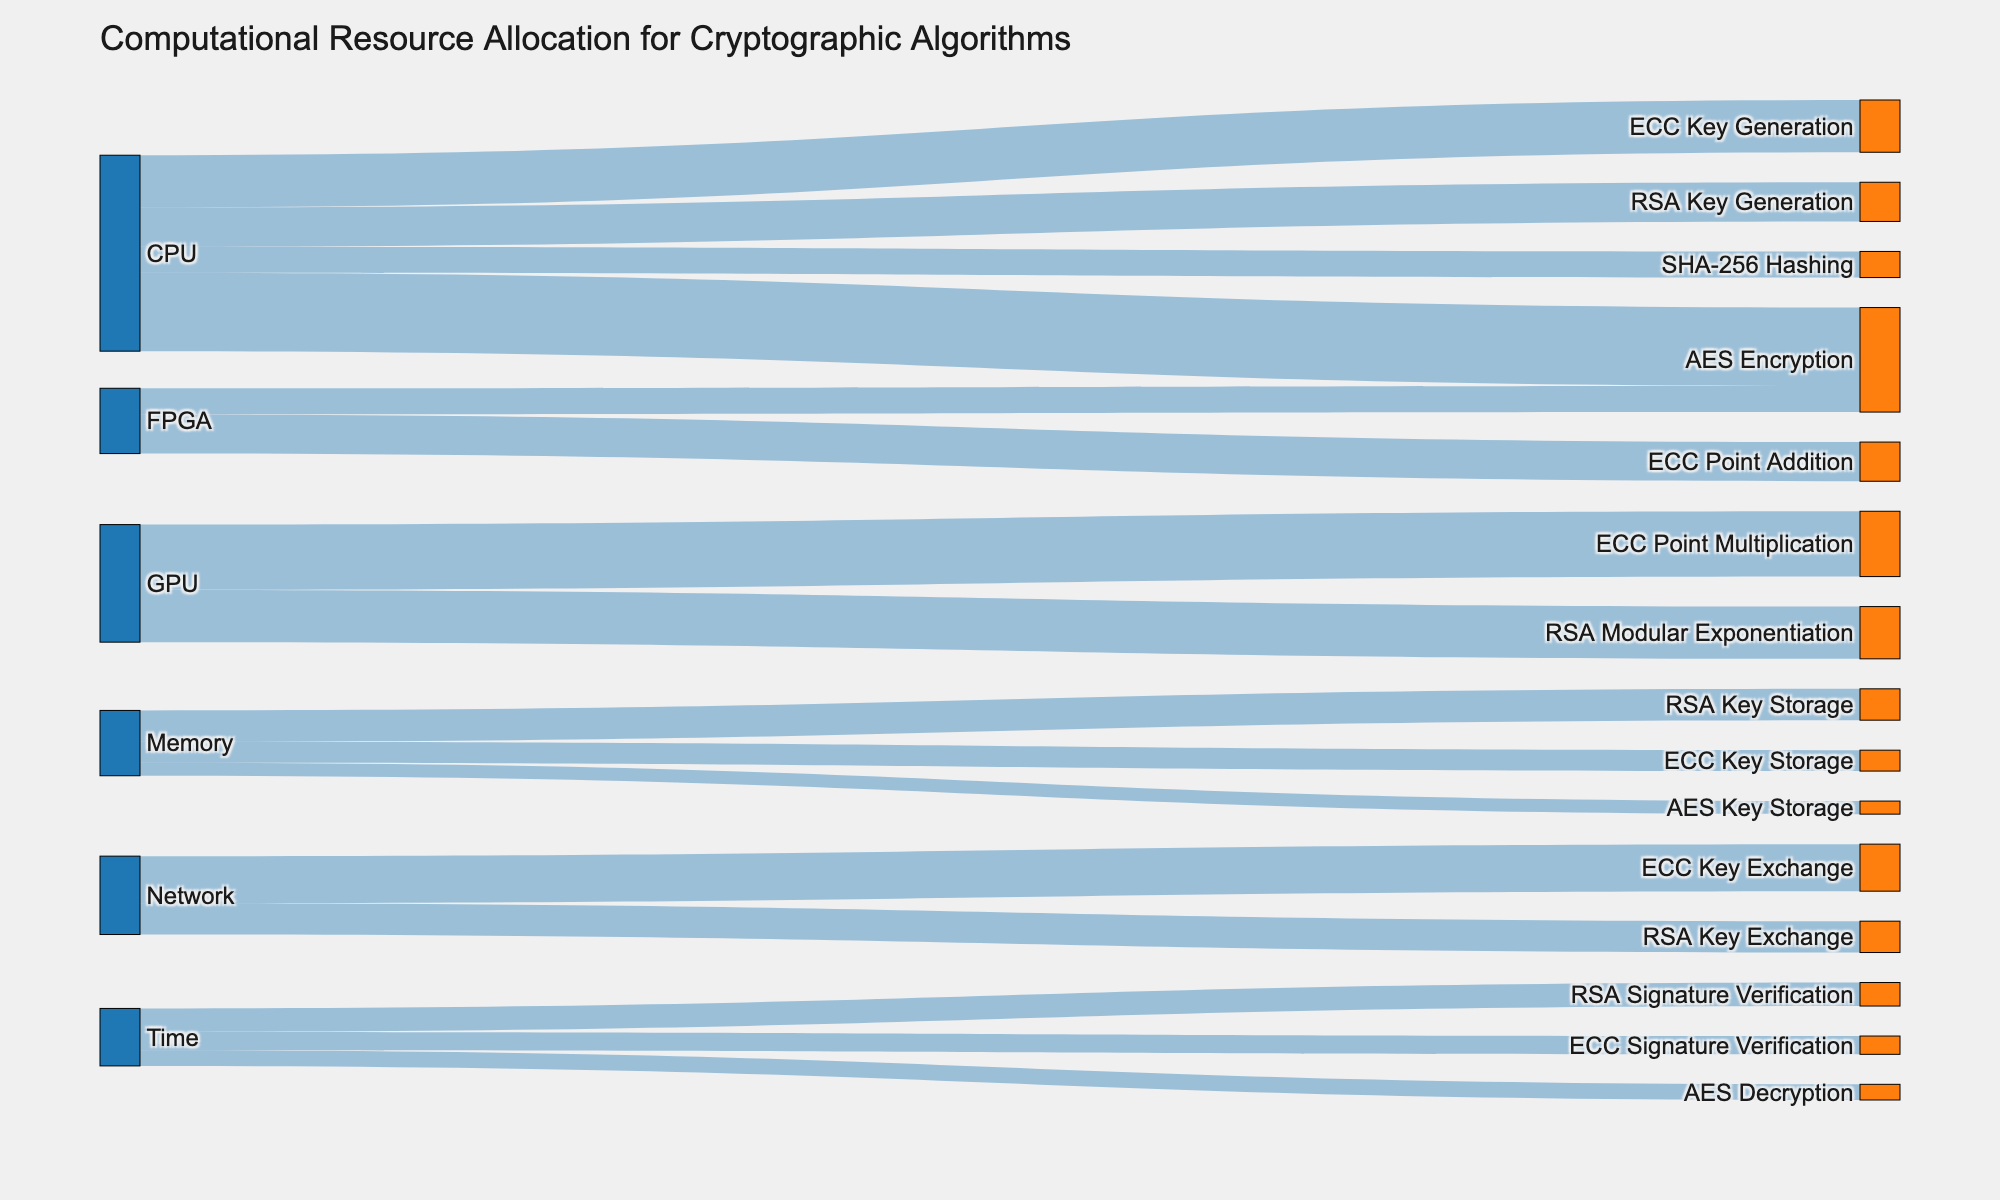What is the title of the Sankey diagram? The title is located at the top of the diagram. It is "Computational Resource Allocation for Cryptographic Algorithms"
Answer: "Computational Resource Allocation for Cryptographic Algorithms" Which computational resource has the highest allocation for ECC-related tasks? From the diagram, examining the connections to ECC-related tasks (ECC Key Generation, ECC Point Multiplication, ECC Point Addition, ECC Key Storage, ECC Key Exchange, ECC Signature Verification), the GPU has a major role for ECC Point Multiplication (25) and ECC Point Addition (15). Summing these gives 40.
Answer: GPU How many different computational resources are represented in the diagram? The different computational resources are indicated by distinct sources connected to a variety of targets. There are four sources: CPU, GPU, FPGA, and Memory.
Answer: 4 What is the total value of computational resources allocated for RSA-related tasks? To find the total value for RSA-related tasks (RSA Key Generation, RSA Modular Exponentiation, RSA Key Storage, RSA Key Exchange, RSA Signature Verification), sum the values from the respective source-targets: 15 (CPU to RSA Key Generation) + 20 (GPU to RSA Modular Exponentiation) + 12 (Memory to RSA Key Storage) + 12 (Network to RSA Key Exchange) + 9 (Time to RSA Signature Verification) = 68.
Answer: 68 Which task utilizes the most computational resources from the FPGA? The FPGA is associated with ECC Point Addition (15) and AES Encryption (10). Comparing these, ECC Point Addition utilizes more resources.
Answer: ECC Point Addition Are there any targets that receive computational resources from more than one type of source? By studying the target nodes, ECC Key Generation receives resources from CPU (20), indicating it comes from a single source. However, examining ECC Point Multiplication (GPU 25) and ECC Point Addition (FPGA 15) suggest no overlap in sources for other targets. A close inspection reveals that RSA Key Exchange receives resources from both Network (12) and Time (9), suggesting it's also connected to more than one source. Summing it confirms a unique allocation per source type.
Answer: No What is the total value of resources coming from the CPU? The CPU distributes resources to multiple targets. Summing these allocations: 30 (AES Encryption) + 15 (RSA Key Generation) + 20 (ECC Key Generation) + 10 (SHA-256 Hashing) results in 75 total from CPU.
Answer: 75 Which algorithm receives the least amount of computational resources for decryption? For decryption tasks, we notice AES Decryption which has a value of 6 directly available in comparison. There is no decryption indicated for other algorithms directly in this dataset.
Answer: AES Decryption How does the resource allocation for ECC Signature Verification compare to RSA Signature Verification? ECC Signature Verification (7) received fewer resources compared to RSA Signature Verification (9). Comparing their values directly shows ECC uses less computational expense here.
Answer: ECC received fewer resources than RSA 